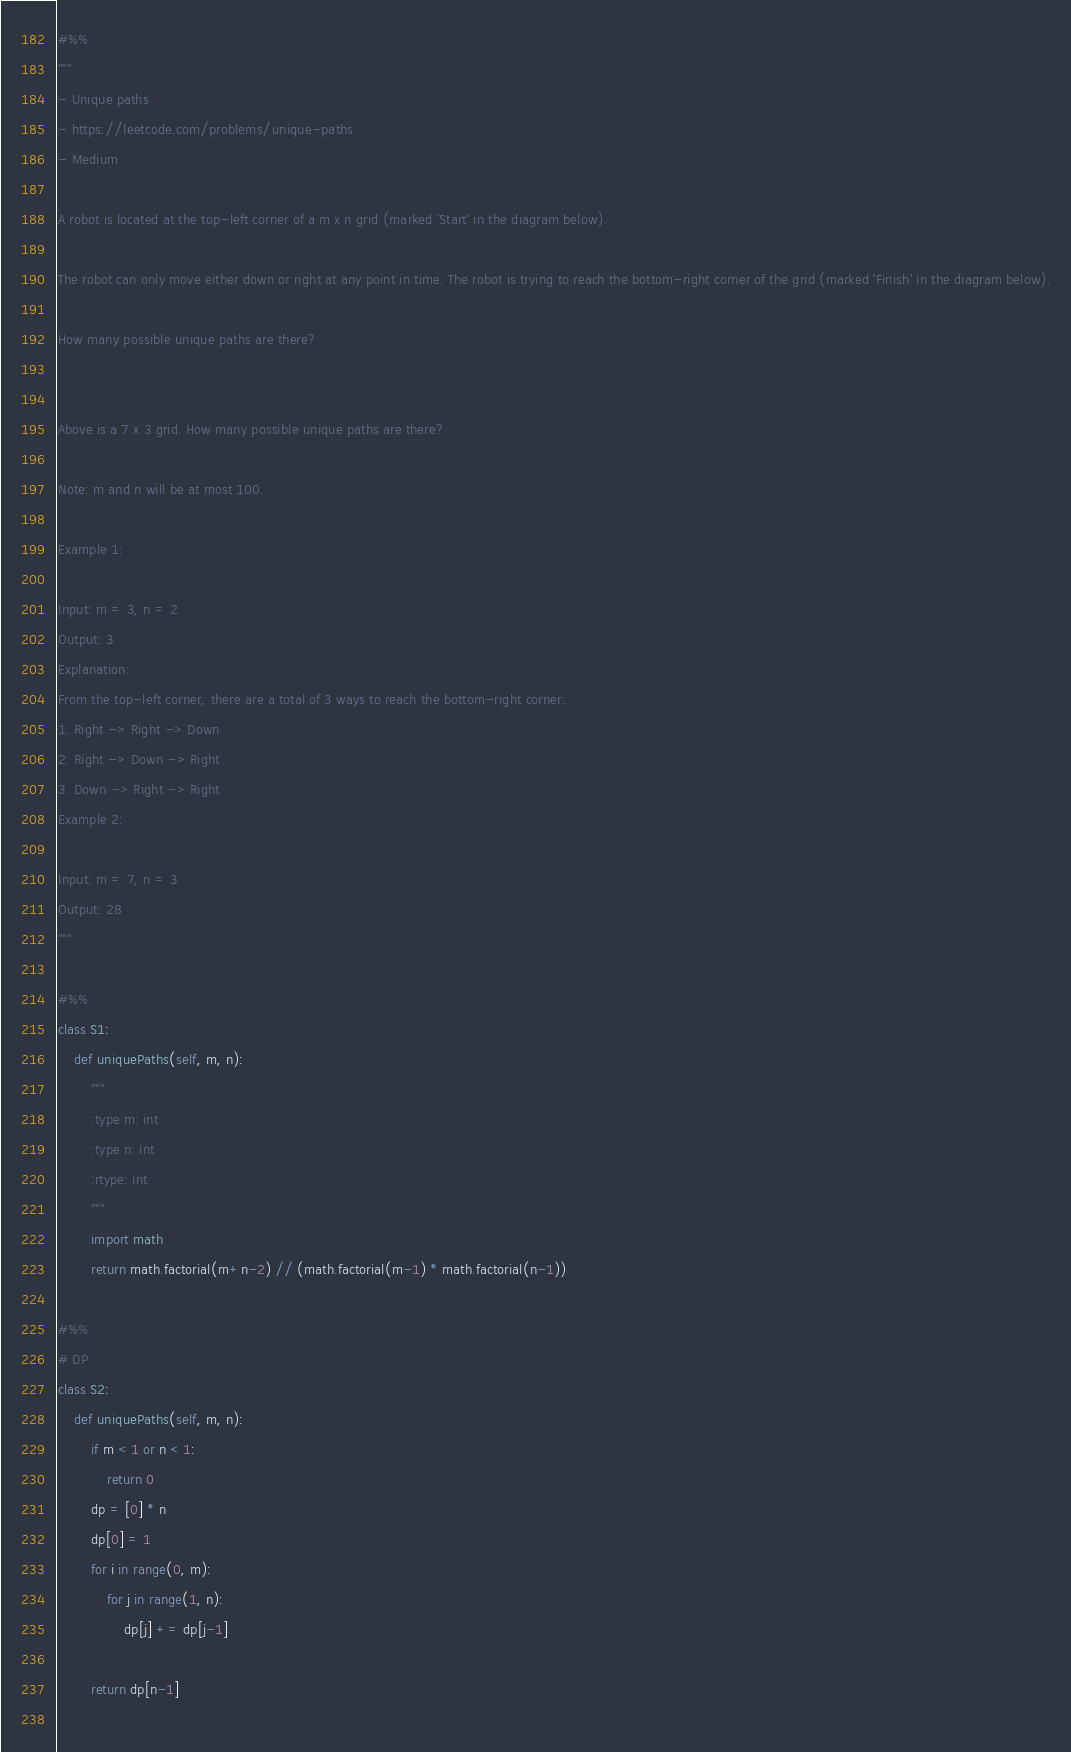Convert code to text. <code><loc_0><loc_0><loc_500><loc_500><_Python_>#%%
"""
- Unique paths
- https://leetcode.com/problems/unique-paths
- Medium

A robot is located at the top-left corner of a m x n grid (marked 'Start' in the diagram below).

The robot can only move either down or right at any point in time. The robot is trying to reach the bottom-right corner of the grid (marked 'Finish' in the diagram below).

How many possible unique paths are there?


Above is a 7 x 3 grid. How many possible unique paths are there?

Note: m and n will be at most 100.

Example 1:

Input: m = 3, n = 2
Output: 3
Explanation:
From the top-left corner, there are a total of 3 ways to reach the bottom-right corner:
1. Right -> Right -> Down
2. Right -> Down -> Right
3. Down -> Right -> Right
Example 2:

Input: m = 7, n = 3
Output: 28
"""

#%%
class S1:
    def uniquePaths(self, m, n):
        """
        :type m: int
        :type n: int
        :rtype: int
        """
        import math
        return math.factorial(m+n-2) // (math.factorial(m-1) * math.factorial(n-1))

#%%
# DP
class S2:
    def uniquePaths(self, m, n):
        if m < 1 or n < 1:
            return 0
        dp = [0] * n
        dp[0] = 1
        for i in range(0, m):
            for j in range(1, n):
                dp[j] += dp[j-1]
        
        return dp[n-1]
        </code> 